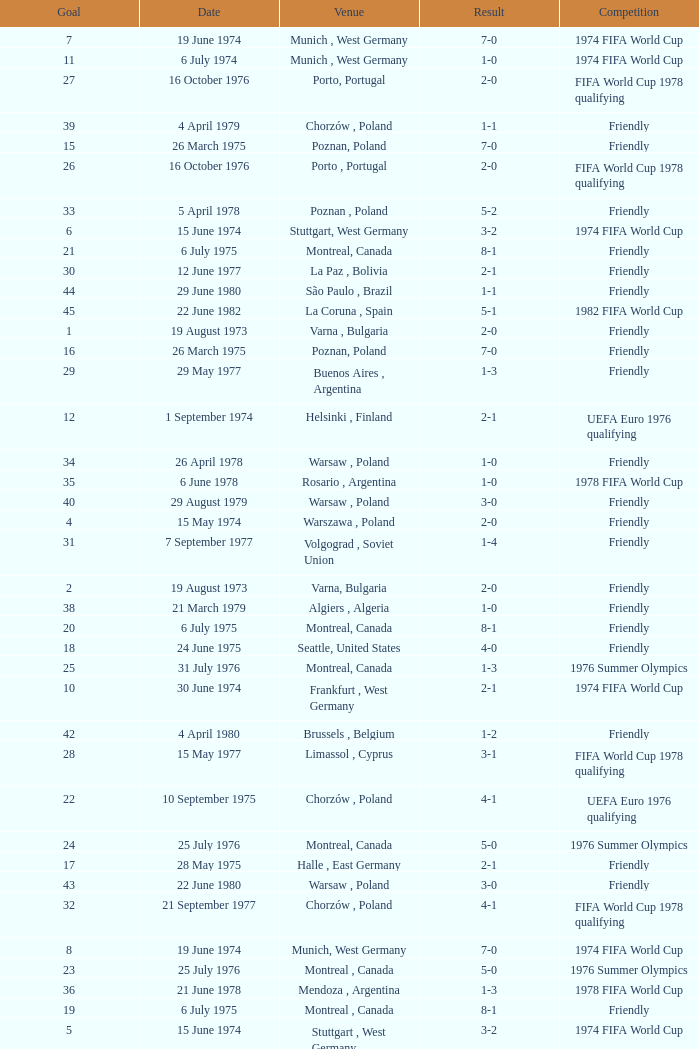What was the result of the game in Stuttgart, West Germany and a goal number of less than 9? 3-2, 3-2. 